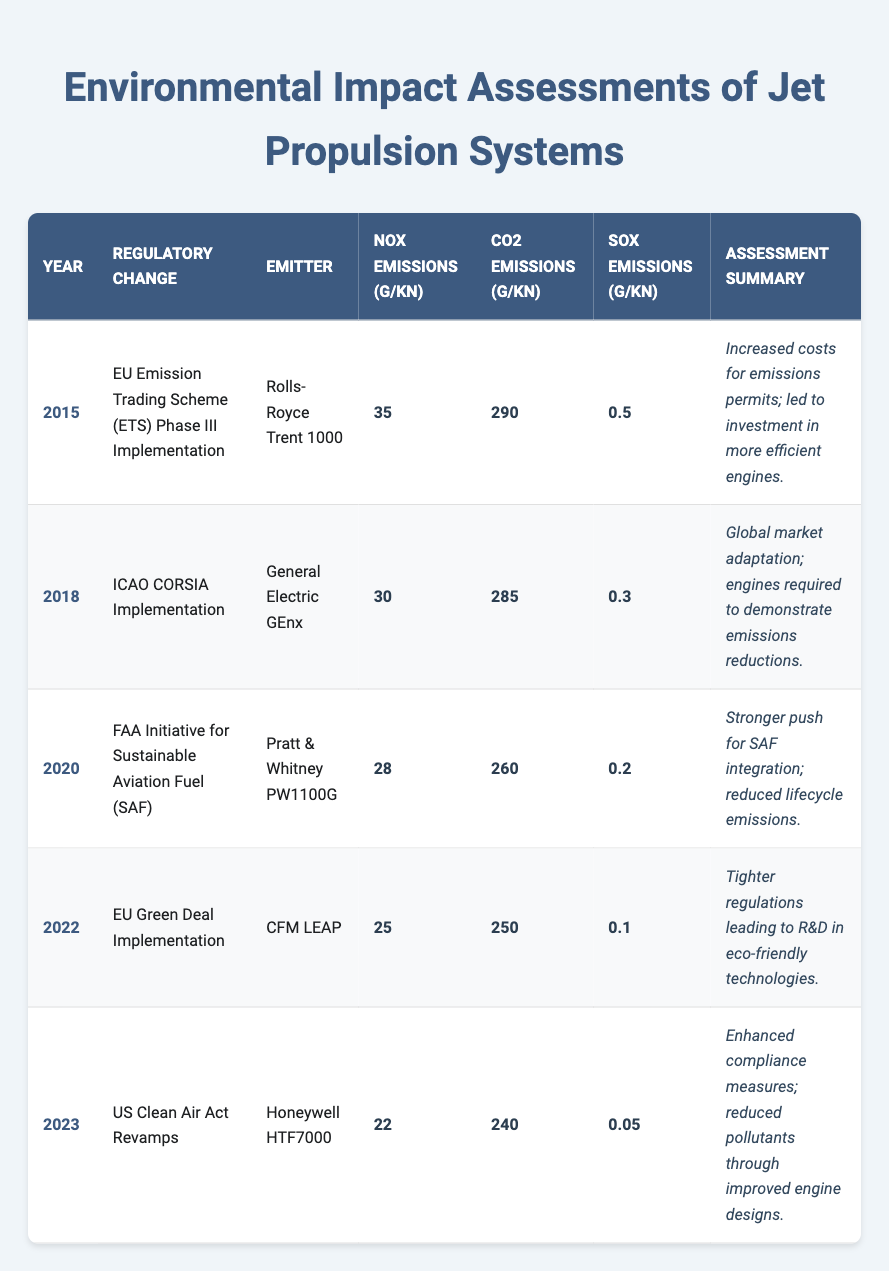What is the NOx emission of the Rolls-Royce Trent 1000? The table lists the emissions for different jet engines. By locating the row for the Rolls-Royce Trent 1000 (2015), the NOx emissions are specified as 35 g/kN.
Answer: 35 g/kN What year did the USDA Clean Air Act revamp occur? The table shows a list of regulatory changes along with their respective years. The revamp of the US Clean Air Act occurred in 2023, as indicated in the table.
Answer: 2023 Which emitter had the lowest SOx emissions, and what were those emissions? Reviewing the table, the lowest SOx emissions are found in the 2023 row for the Honeywell HTF7000, which recorded 0.05 g/kN.
Answer: Honeywell HTF7000, 0.05 g/kN What was the change in CO2 emissions from 2015 to 2023? The CO2 emissions for 2015 are 290 g/kN for the Rolls-Royce Trent 1000, and for 2023, it is 240 g/kN for the Honeywell HTF7000. The difference is 290 - 240 = 50 g/kN.
Answer: 50 g/kN Did the NOx emissions decrease across the years listed? By examining the NOx emissions recorded for each year in the table, we find a decreasing trend: 35, 30, 28, 25, 22 g/kN. Therefore, it can be concluded that NOx emissions did decrease over this period.
Answer: Yes What average CO2 emissions were recorded for the period from 2015 to 2023? To find the average CO2 emissions, we sum the values: 290 + 285 + 260 + 250 + 240 = 1325 g/kN, and then divide by the number of years (5). The average CO2 emissions are 1325 / 5 = 265 g/kN.
Answer: 265 g/kN In which year did the CORSIA implementation take place, and how do its NOx emissions compare to the following year? The CORSIA implementation occurred in 2018, with NOx emissions of 30 g/kN. In the following year, 2020, NOx emissions were lower at 28 g/kN, indicating a decrease.
Answer: 2018, lower Which emitter saw the most significant reduction in CO2 emissions between the two years where they were reported? To identify the most significant reduction, we observe the two years: from 2015 to 2023, CO2 emissions fell from 290 g/kN to 240 g/kN, a reduction of 50 g/kN. The Rolls-Royce Trent 1000 shows the largest decline across the years reported.
Answer: Rolls-Royce Trent 1000, 50 g/kN reduction 